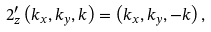<formula> <loc_0><loc_0><loc_500><loc_500>2 _ { z } ^ { \prime } \left ( k _ { x } , k _ { y } , k \right ) = \left ( k _ { x } , k _ { y } , - k \right ) ,</formula> 